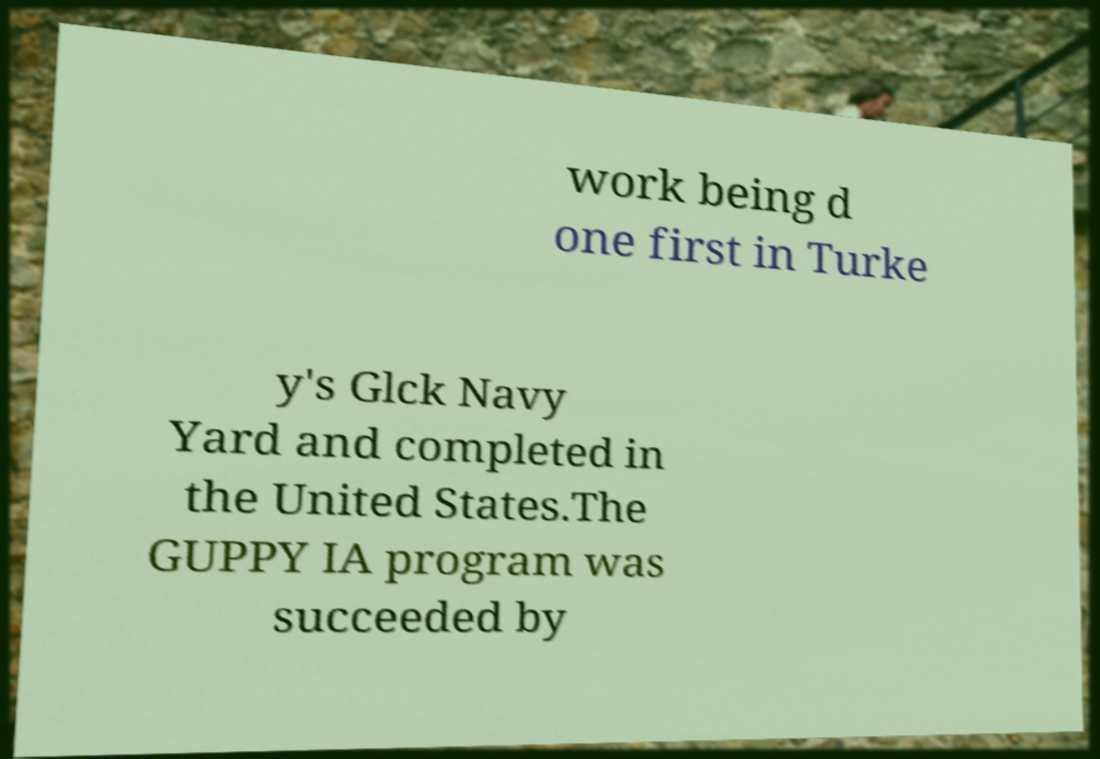Could you extract and type out the text from this image? work being d one first in Turke y's Glck Navy Yard and completed in the United States.The GUPPY IA program was succeeded by 